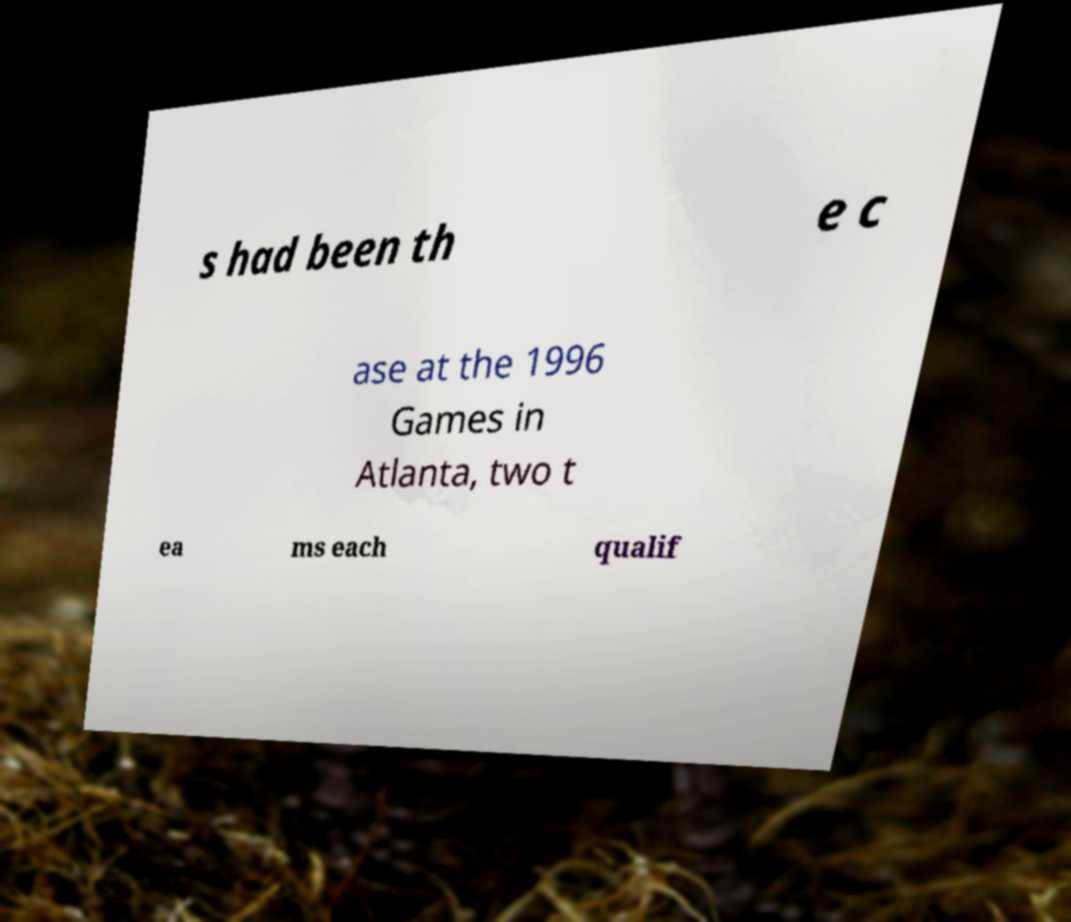For documentation purposes, I need the text within this image transcribed. Could you provide that? s had been th e c ase at the 1996 Games in Atlanta, two t ea ms each qualif 